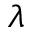<formula> <loc_0><loc_0><loc_500><loc_500>\lambda</formula> 